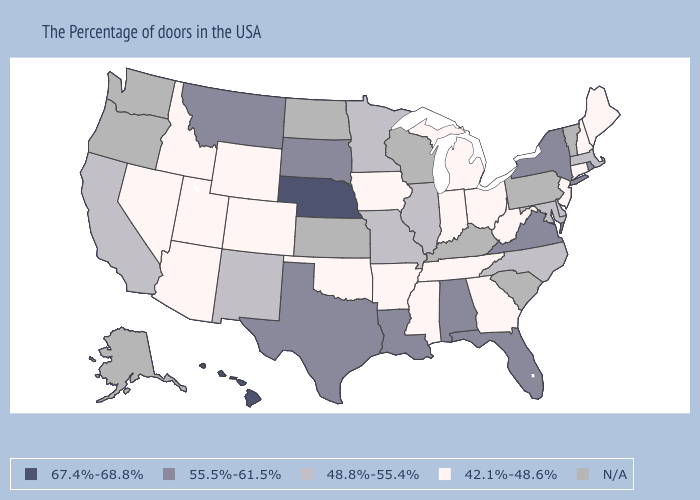Does Massachusetts have the lowest value in the USA?
Write a very short answer. No. What is the value of North Carolina?
Quick response, please. 48.8%-55.4%. Name the states that have a value in the range 67.4%-68.8%?
Short answer required. Nebraska, Hawaii. What is the highest value in the USA?
Be succinct. 67.4%-68.8%. What is the value of Wyoming?
Write a very short answer. 42.1%-48.6%. What is the value of Pennsylvania?
Write a very short answer. N/A. What is the value of Tennessee?
Short answer required. 42.1%-48.6%. Among the states that border Nevada , which have the highest value?
Be succinct. California. Does Utah have the lowest value in the USA?
Write a very short answer. Yes. Is the legend a continuous bar?
Quick response, please. No. What is the highest value in the USA?
Answer briefly. 67.4%-68.8%. Name the states that have a value in the range 42.1%-48.6%?
Keep it brief. Maine, New Hampshire, Connecticut, New Jersey, West Virginia, Ohio, Georgia, Michigan, Indiana, Tennessee, Mississippi, Arkansas, Iowa, Oklahoma, Wyoming, Colorado, Utah, Arizona, Idaho, Nevada. What is the value of Washington?
Give a very brief answer. N/A. 